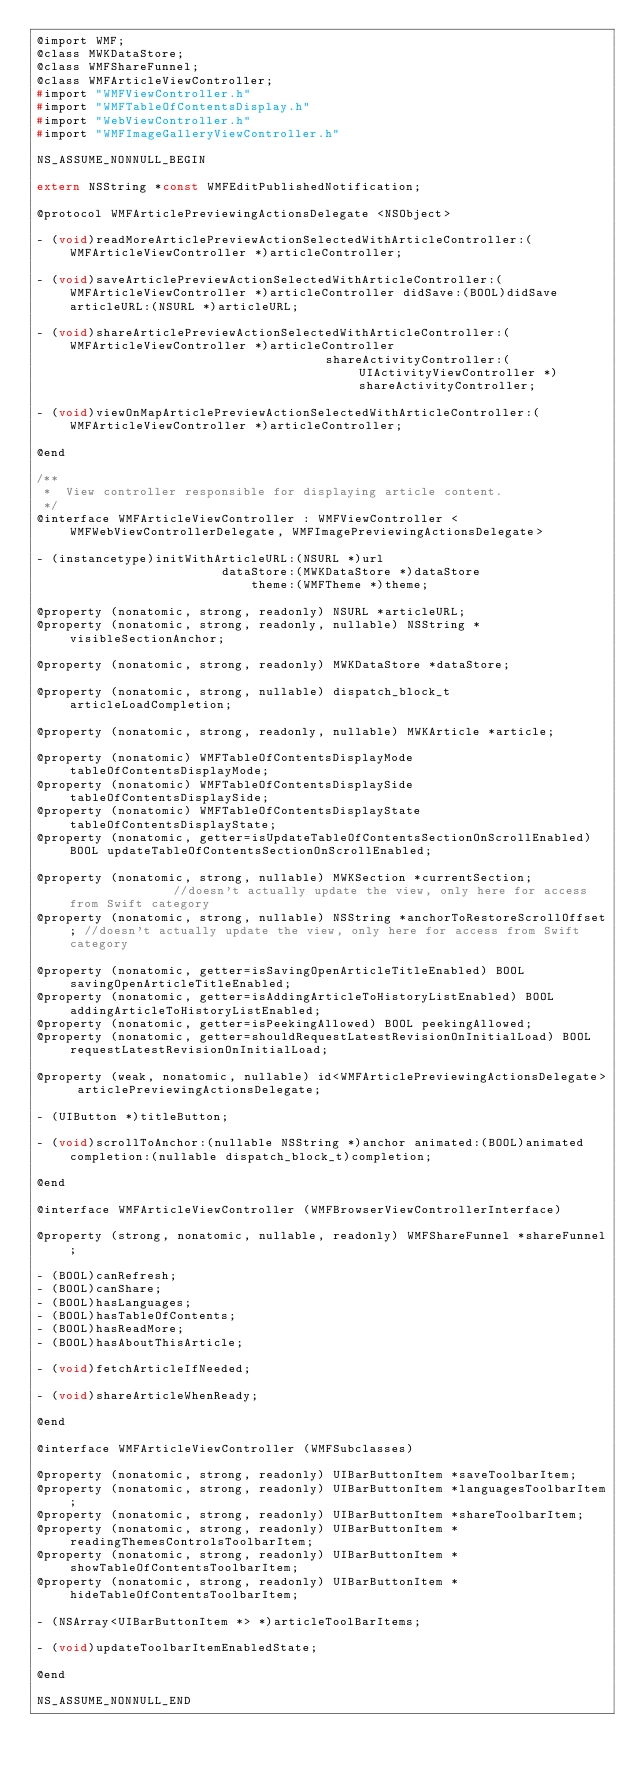<code> <loc_0><loc_0><loc_500><loc_500><_C_>@import WMF;
@class MWKDataStore;
@class WMFShareFunnel;
@class WMFArticleViewController;
#import "WMFViewController.h"
#import "WMFTableOfContentsDisplay.h"
#import "WebViewController.h"
#import "WMFImageGalleryViewController.h"

NS_ASSUME_NONNULL_BEGIN

extern NSString *const WMFEditPublishedNotification;

@protocol WMFArticlePreviewingActionsDelegate <NSObject>

- (void)readMoreArticlePreviewActionSelectedWithArticleController:(WMFArticleViewController *)articleController;

- (void)saveArticlePreviewActionSelectedWithArticleController:(WMFArticleViewController *)articleController didSave:(BOOL)didSave articleURL:(NSURL *)articleURL;

- (void)shareArticlePreviewActionSelectedWithArticleController:(WMFArticleViewController *)articleController
                                       shareActivityController:(UIActivityViewController *)shareActivityController;

- (void)viewOnMapArticlePreviewActionSelectedWithArticleController:(WMFArticleViewController *)articleController;

@end

/**
 *  View controller responsible for displaying article content.
 */
@interface WMFArticleViewController : WMFViewController <WMFWebViewControllerDelegate, WMFImagePreviewingActionsDelegate>

- (instancetype)initWithArticleURL:(NSURL *)url
                         dataStore:(MWKDataStore *)dataStore
                             theme:(WMFTheme *)theme;

@property (nonatomic, strong, readonly) NSURL *articleURL;
@property (nonatomic, strong, readonly, nullable) NSString *visibleSectionAnchor;

@property (nonatomic, strong, readonly) MWKDataStore *dataStore;

@property (nonatomic, strong, nullable) dispatch_block_t articleLoadCompletion;

@property (nonatomic, strong, readonly, nullable) MWKArticle *article;

@property (nonatomic) WMFTableOfContentsDisplayMode tableOfContentsDisplayMode;
@property (nonatomic) WMFTableOfContentsDisplaySide tableOfContentsDisplaySide;
@property (nonatomic) WMFTableOfContentsDisplayState tableOfContentsDisplayState;
@property (nonatomic, getter=isUpdateTableOfContentsSectionOnScrollEnabled) BOOL updateTableOfContentsSectionOnScrollEnabled;

@property (nonatomic, strong, nullable) MWKSection *currentSection;               //doesn't actually update the view, only here for access from Swift category
@property (nonatomic, strong, nullable) NSString *anchorToRestoreScrollOffset; //doesn't actually update the view, only here for access from Swift category

@property (nonatomic, getter=isSavingOpenArticleTitleEnabled) BOOL savingOpenArticleTitleEnabled;
@property (nonatomic, getter=isAddingArticleToHistoryListEnabled) BOOL addingArticleToHistoryListEnabled;
@property (nonatomic, getter=isPeekingAllowed) BOOL peekingAllowed;
@property (nonatomic, getter=shouldRequestLatestRevisionOnInitialLoad) BOOL requestLatestRevisionOnInitialLoad;

@property (weak, nonatomic, nullable) id<WMFArticlePreviewingActionsDelegate> articlePreviewingActionsDelegate;

- (UIButton *)titleButton;

- (void)scrollToAnchor:(nullable NSString *)anchor animated:(BOOL)animated completion:(nullable dispatch_block_t)completion;

@end

@interface WMFArticleViewController (WMFBrowserViewControllerInterface)

@property (strong, nonatomic, nullable, readonly) WMFShareFunnel *shareFunnel;

- (BOOL)canRefresh;
- (BOOL)canShare;
- (BOOL)hasLanguages;
- (BOOL)hasTableOfContents;
- (BOOL)hasReadMore;
- (BOOL)hasAboutThisArticle;

- (void)fetchArticleIfNeeded;

- (void)shareArticleWhenReady;

@end

@interface WMFArticleViewController (WMFSubclasses)

@property (nonatomic, strong, readonly) UIBarButtonItem *saveToolbarItem;
@property (nonatomic, strong, readonly) UIBarButtonItem *languagesToolbarItem;
@property (nonatomic, strong, readonly) UIBarButtonItem *shareToolbarItem;
@property (nonatomic, strong, readonly) UIBarButtonItem *readingThemesControlsToolbarItem;
@property (nonatomic, strong, readonly) UIBarButtonItem *showTableOfContentsToolbarItem;
@property (nonatomic, strong, readonly) UIBarButtonItem *hideTableOfContentsToolbarItem;

- (NSArray<UIBarButtonItem *> *)articleToolBarItems;

- (void)updateToolbarItemEnabledState;

@end

NS_ASSUME_NONNULL_END
</code> 